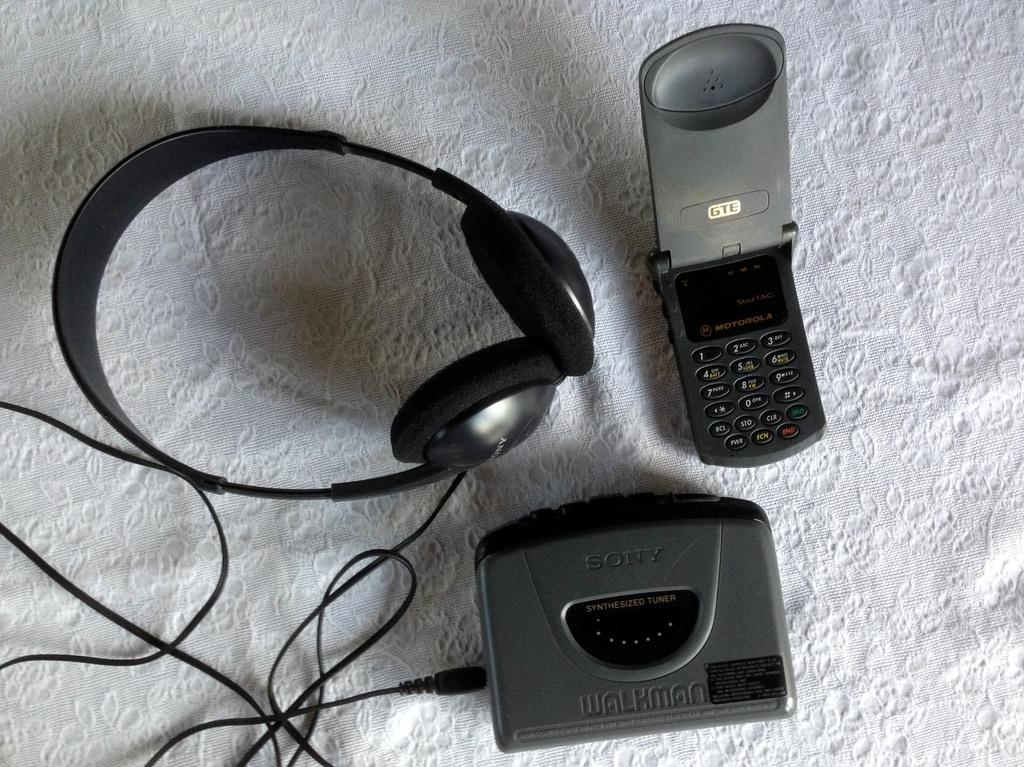What type of music player is in the image? There is a black color walkman in the image. What other electronic device is in the image? There is a cell phone in the image. What is used for listening to audio from the walkman? There is a headphone in the image. What connects the walkman to the headphone? There is a black color wire in the image. What is under the electronic devices in the image? There is a white cloth under these items in the image. What degree of difficulty is required to assemble the wheel in the image? There is no wheel present in the image, so it is not possible to answer a question about assembling it. 